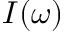Convert formula to latex. <formula><loc_0><loc_0><loc_500><loc_500>I ( \omega )</formula> 